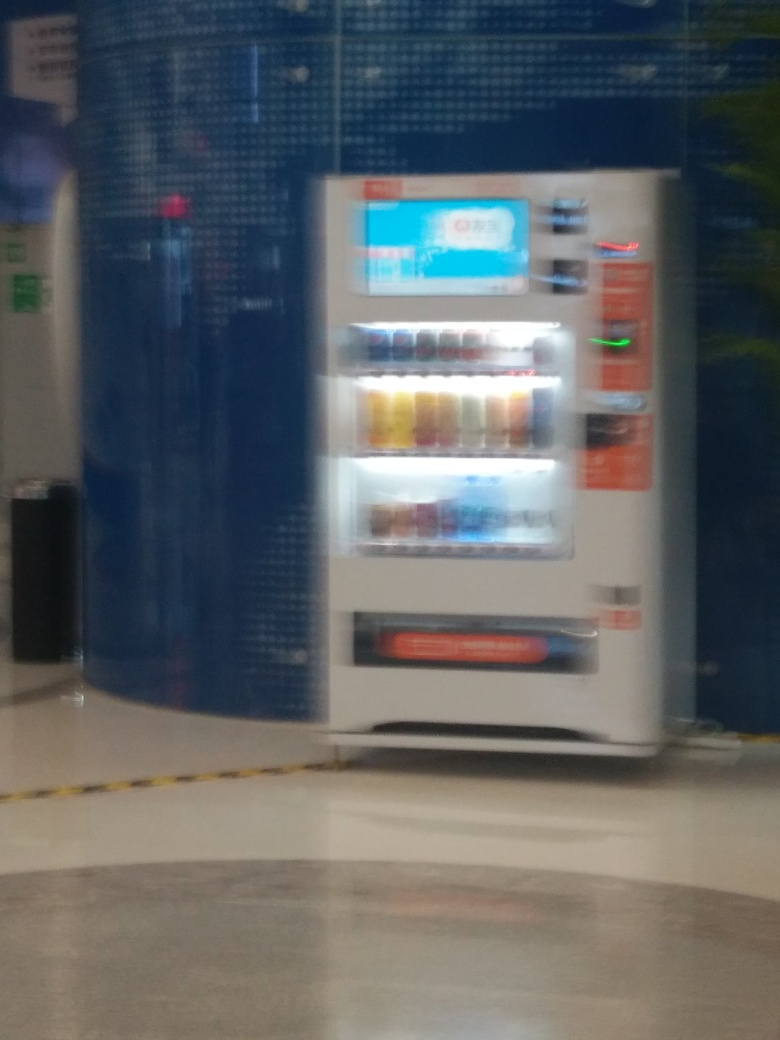Can you describe the lighting conditions in the image? The lighting conditions seem to be artificial, as the image has a yellowish tint that often comes from indoor lighting. The reflection on the floor also suggests the presence of overhead lights. Why is it important to consider lighting when assessing photo quality? Lighting is crucial when assessing photo quality as it affects the image's clarity, color balance, and the ability to capture details. Poor lighting can result in a blurry or poorly exposed photograph. 